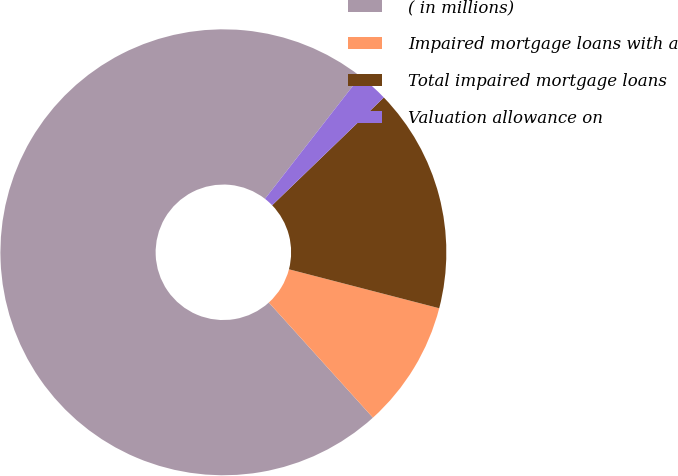<chart> <loc_0><loc_0><loc_500><loc_500><pie_chart><fcel>( in millions)<fcel>Impaired mortgage loans with a<fcel>Total impaired mortgage loans<fcel>Valuation allowance on<nl><fcel>72.22%<fcel>9.26%<fcel>16.25%<fcel>2.26%<nl></chart> 